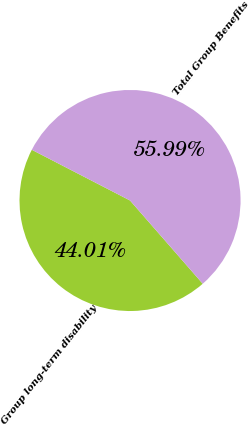Convert chart. <chart><loc_0><loc_0><loc_500><loc_500><pie_chart><fcel>Group long-term disability<fcel>Total Group Benefits<nl><fcel>44.01%<fcel>55.99%<nl></chart> 